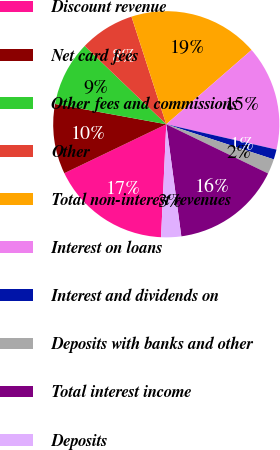Convert chart to OTSL. <chart><loc_0><loc_0><loc_500><loc_500><pie_chart><fcel>Discount revenue<fcel>Net card fees<fcel>Other fees and commissions<fcel>Other<fcel>Total non-interest revenues<fcel>Interest on loans<fcel>Interest and dividends on<fcel>Deposits with banks and other<fcel>Total interest income<fcel>Deposits<nl><fcel>17.14%<fcel>10.0%<fcel>9.29%<fcel>7.86%<fcel>18.57%<fcel>15.0%<fcel>1.43%<fcel>2.14%<fcel>15.71%<fcel>2.86%<nl></chart> 